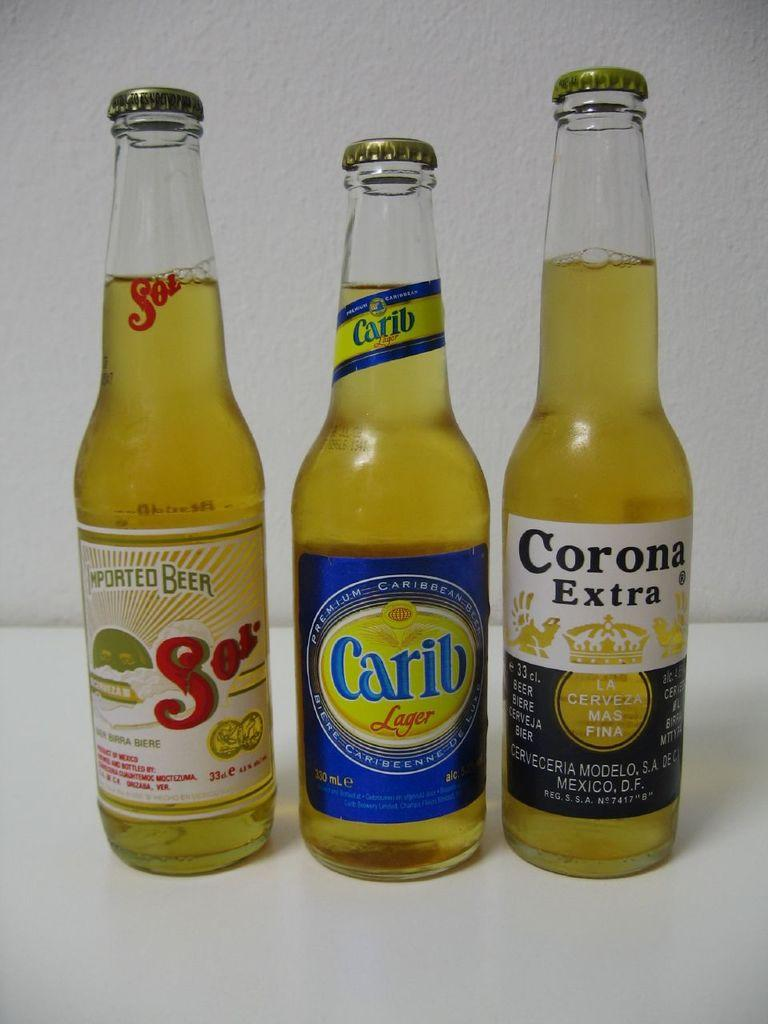Provide a one-sentence caption for the provided image. Three beer bottles Sol, Carib and Corona Extra. 